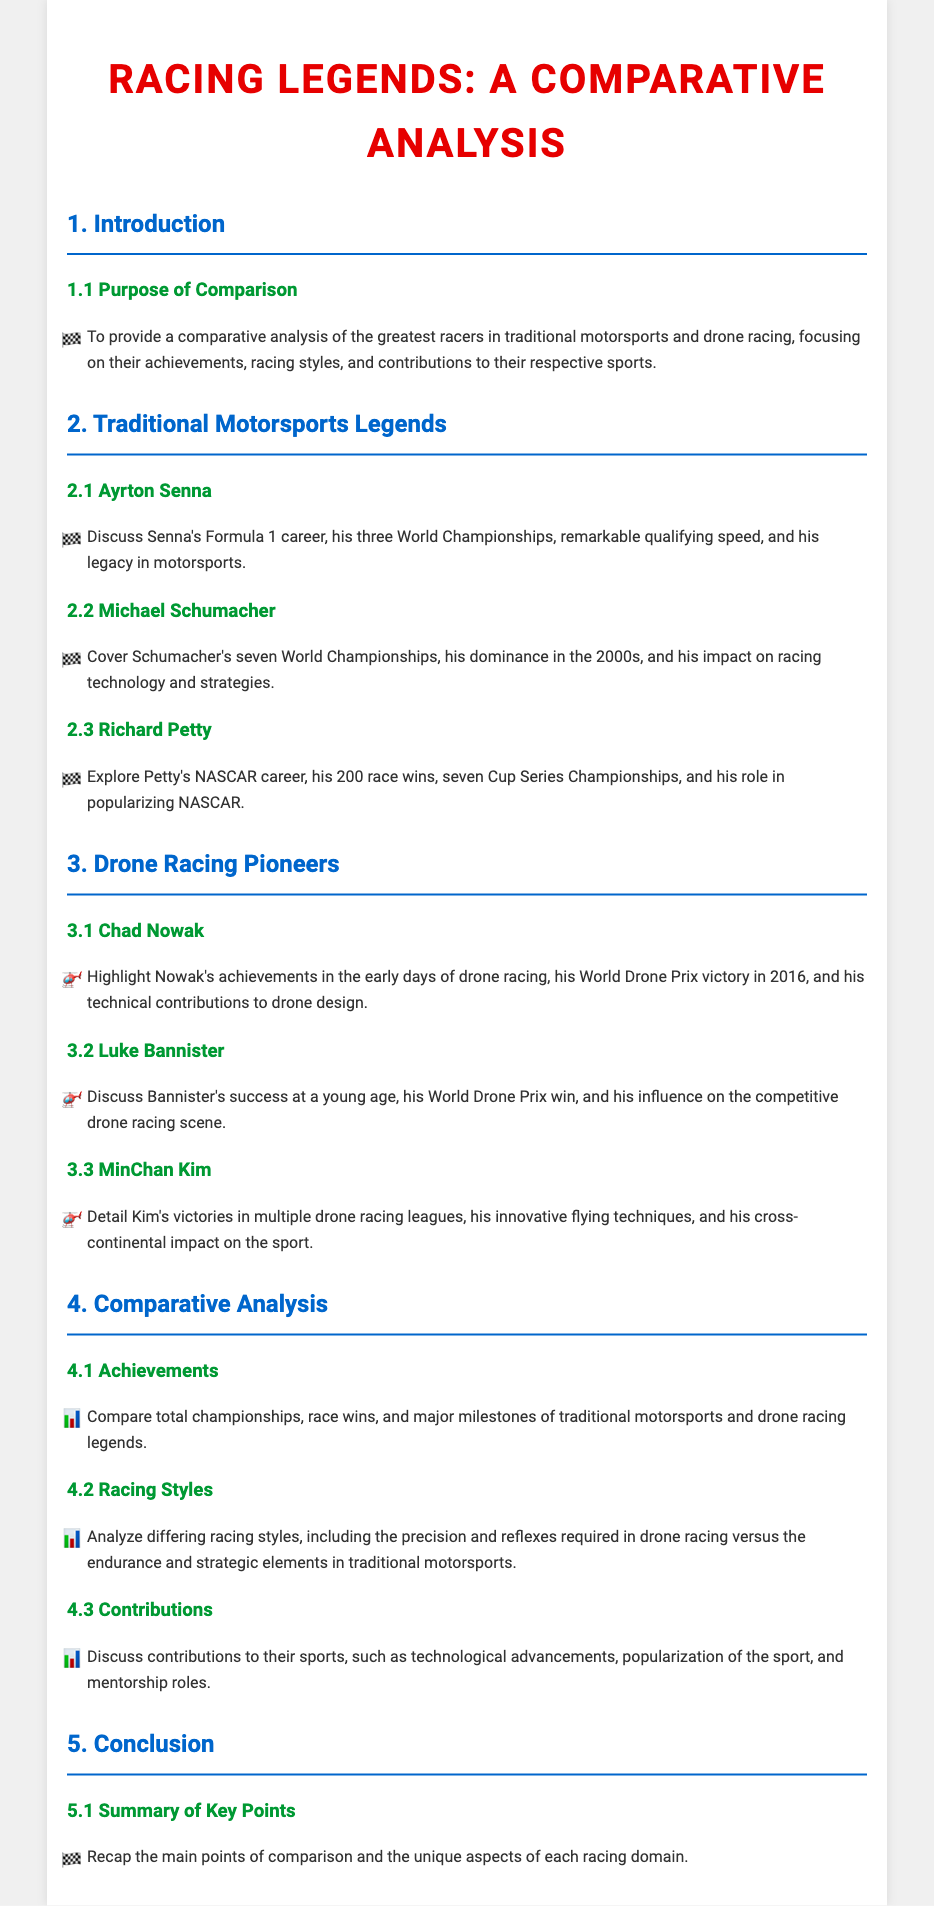What is the purpose of the comparison? The purpose is clearly stated in the document as providing a comparative analysis of the greatest racers in traditional motorsports and drone racing.
Answer: comparative analysis of the greatest racers How many World Championships did Ayrton Senna win? The document specifies that Ayrton Senna won three World Championships during his Formula 1 career.
Answer: three Which NASCAR legend had 200 race wins? The document highlights Richard Petty for his remarkable achievement of 200 race wins in NASCAR.
Answer: Richard Petty What significant event did Chad Nowak win in 2016? The document mentions that Chad Nowak achieved victory in the World Drone Prix in 2016.
Answer: World Drone Prix Which racer is known for innovative flying techniques? The text notes MinChan Kim's innovative flying techniques in multiple drone racing leagues.
Answer: MinChan Kim What do drone racing and traditional motorsports require that differs from each other? The document contrasts precision and reflexes required in drone racing versus endurance and strategic elements in traditional motorsports.
Answer: precision and reflexes vs. endurance and strategic elements Who is mentioned as having an impact on the competitive drone racing scene? The document discusses Luke Bannister's influence on the competitive drone racing scene at a young age.
Answer: Luke Bannister What is discussed in the contributions section of the comparative analysis? The contributions section covers technological advancements, popularization of the sport, and mentorship roles in both sports.
Answer: technological advancements, popularization of the sport, mentorship roles What is the summary of key points found? The summary of key points recaps the main aspects of comparison and unique features of each racing domain.
Answer: main aspects of comparison and unique features 